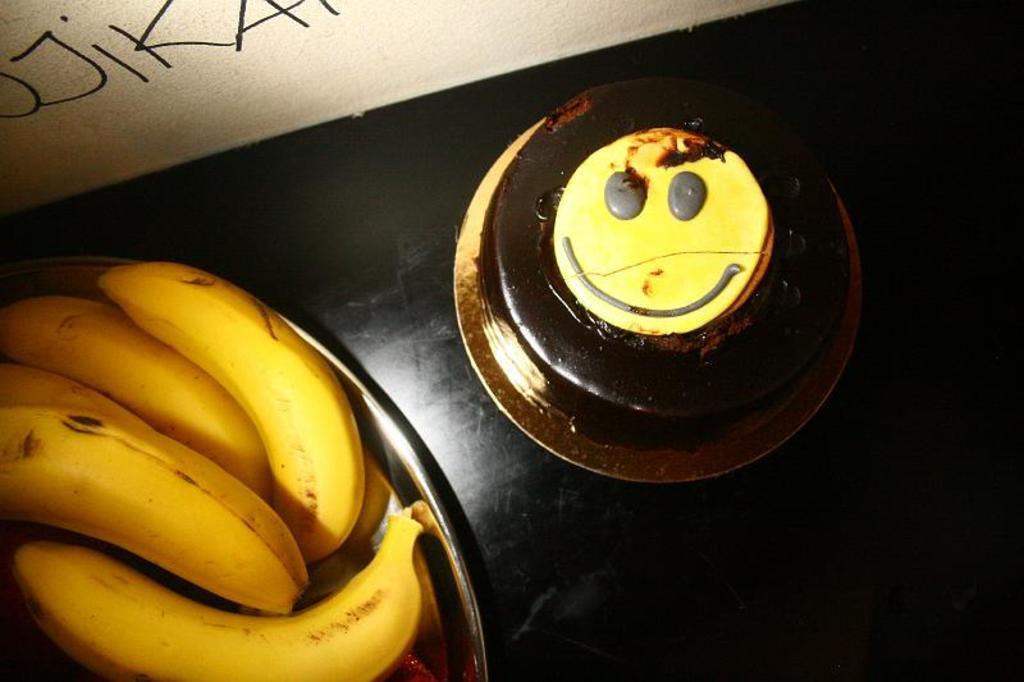In one or two sentences, can you explain what this image depicts? In this image I can see a table on which a plate which consists of bananas and a cake are placed. At the top there is a wall on which I can see some text. 